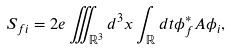<formula> <loc_0><loc_0><loc_500><loc_500>S _ { f i } = 2 e \iiint _ { \mathbb { R } ^ { 3 } } d ^ { 3 } x \int _ { \mathbb { R } } d t \phi _ { f } ^ { * } A \phi _ { i } ,</formula> 